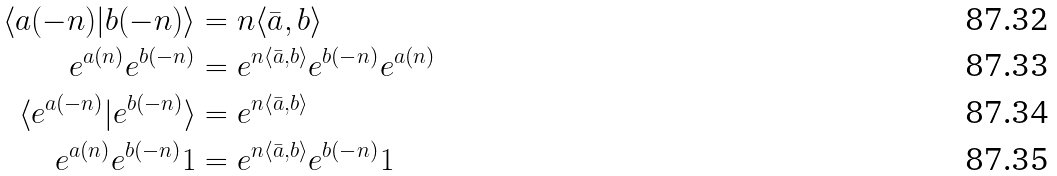Convert formula to latex. <formula><loc_0><loc_0><loc_500><loc_500>\langle a ( - n ) | b ( - n ) \rangle & = n \langle \bar { a } , b \rangle \\ e ^ { a ( n ) } e ^ { b ( - n ) } & = e ^ { n \langle \bar { a } , b \rangle } e ^ { b ( - n ) } e ^ { a ( n ) } \\ \langle e ^ { a ( - n ) } | e ^ { b ( - n ) } \rangle & = e ^ { n \langle \bar { a } , b \rangle } \\ e ^ { a ( n ) } e ^ { b ( - n ) } 1 & = e ^ { n \langle \bar { a } , b \rangle } e ^ { b ( - n ) } 1</formula> 